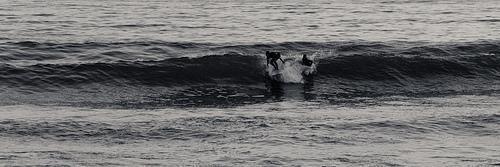How many people are surfing?
Give a very brief answer. 2. How many surfboards are there?
Give a very brief answer. 2. How many big waves are there?
Give a very brief answer. 1. 